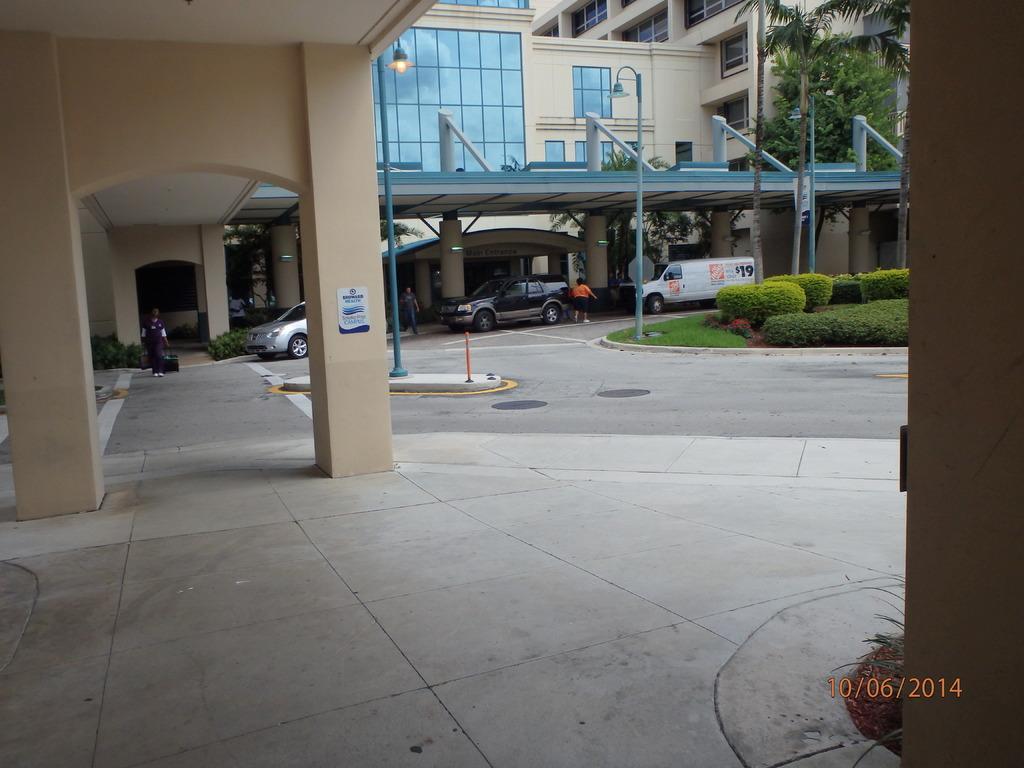How would you summarize this image in a sentence or two? There is a building with pillars and windows. Near to the building there are vehicles. Also there are bushes, light poles and trees. In the right bottom corner there is a watermark. 